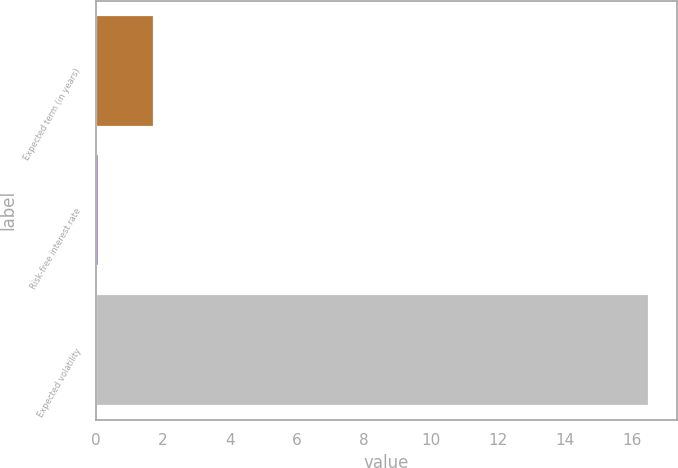<chart> <loc_0><loc_0><loc_500><loc_500><bar_chart><fcel>Expected term (in years)<fcel>Risk-free interest rate<fcel>Expected volatility<nl><fcel>1.74<fcel>0.1<fcel>16.5<nl></chart> 